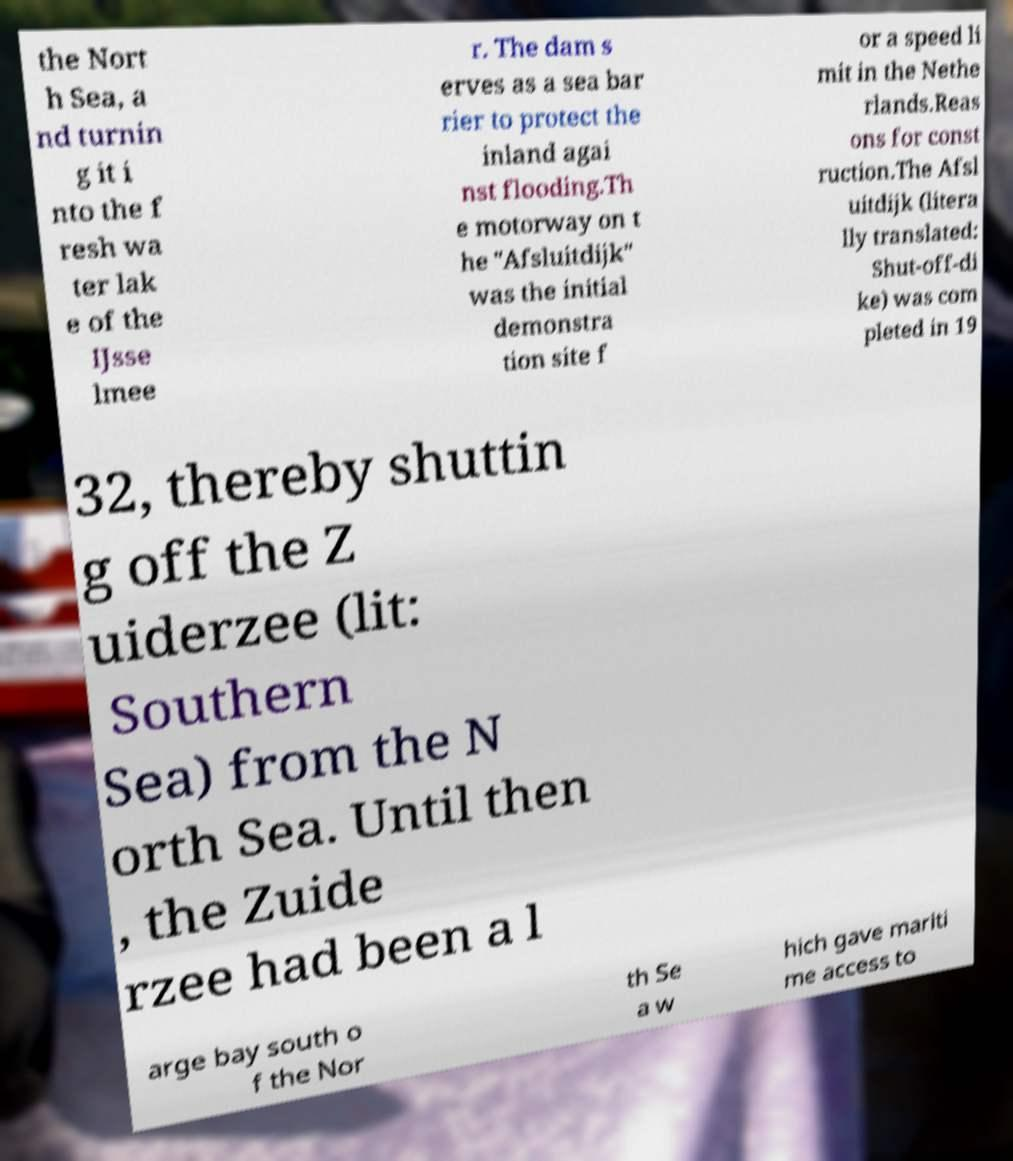Can you accurately transcribe the text from the provided image for me? the Nort h Sea, a nd turnin g it i nto the f resh wa ter lak e of the IJsse lmee r. The dam s erves as a sea bar rier to protect the inland agai nst flooding.Th e motorway on t he "Afsluitdijk" was the initial demonstra tion site f or a speed li mit in the Nethe rlands.Reas ons for const ruction.The Afsl uitdijk (litera lly translated: Shut-off-di ke) was com pleted in 19 32, thereby shuttin g off the Z uiderzee (lit: Southern Sea) from the N orth Sea. Until then , the Zuide rzee had been a l arge bay south o f the Nor th Se a w hich gave mariti me access to 